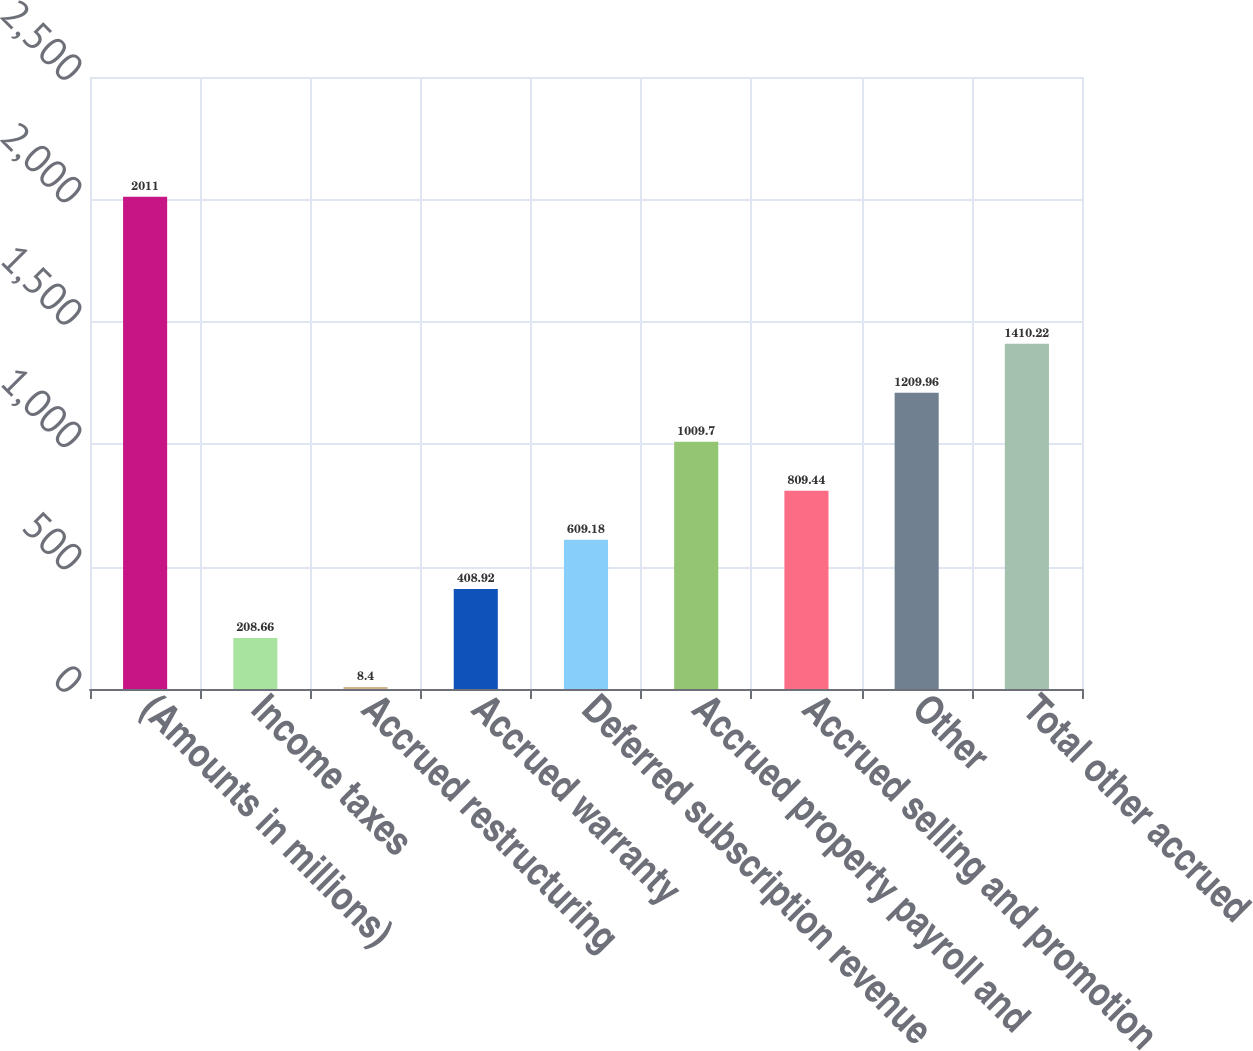<chart> <loc_0><loc_0><loc_500><loc_500><bar_chart><fcel>(Amounts in millions)<fcel>Income taxes<fcel>Accrued restructuring<fcel>Accrued warranty<fcel>Deferred subscription revenue<fcel>Accrued property payroll and<fcel>Accrued selling and promotion<fcel>Other<fcel>Total other accrued<nl><fcel>2011<fcel>208.66<fcel>8.4<fcel>408.92<fcel>609.18<fcel>1009.7<fcel>809.44<fcel>1209.96<fcel>1410.22<nl></chart> 